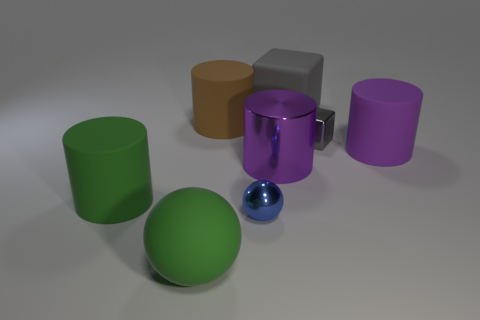What is the material of the other small block that is the same color as the rubber cube?
Offer a very short reply. Metal. What number of metal objects are there?
Keep it short and to the point. 3. There is a brown thing that is the same size as the purple shiny cylinder; what material is it?
Give a very brief answer. Rubber. Are there any green balls that have the same size as the brown matte cylinder?
Your response must be concise. Yes. Do the tiny thing on the right side of the rubber cube and the big object that is behind the brown rubber object have the same color?
Give a very brief answer. Yes. What number of metal things are either green cylinders or purple objects?
Give a very brief answer. 1. There is a small sphere on the right side of the large green thing behind the tiny blue sphere; how many matte balls are to the right of it?
Make the answer very short. 0. There is a sphere that is the same material as the brown thing; what is its size?
Offer a terse response. Large. How many large metal cylinders have the same color as the tiny cube?
Offer a terse response. 0. Does the cylinder to the left of the brown cylinder have the same size as the blue shiny sphere?
Keep it short and to the point. No. 